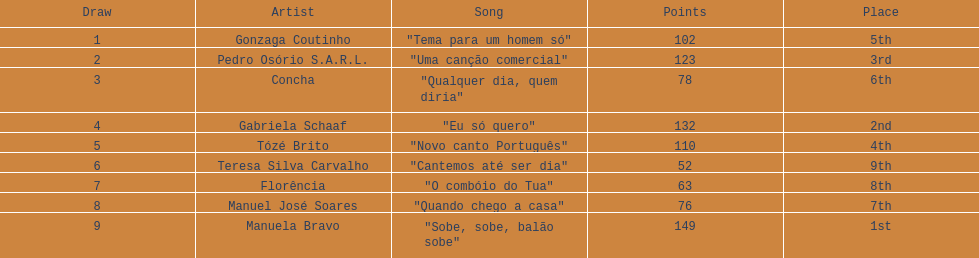What is the total amount of points for florencia? 63. 